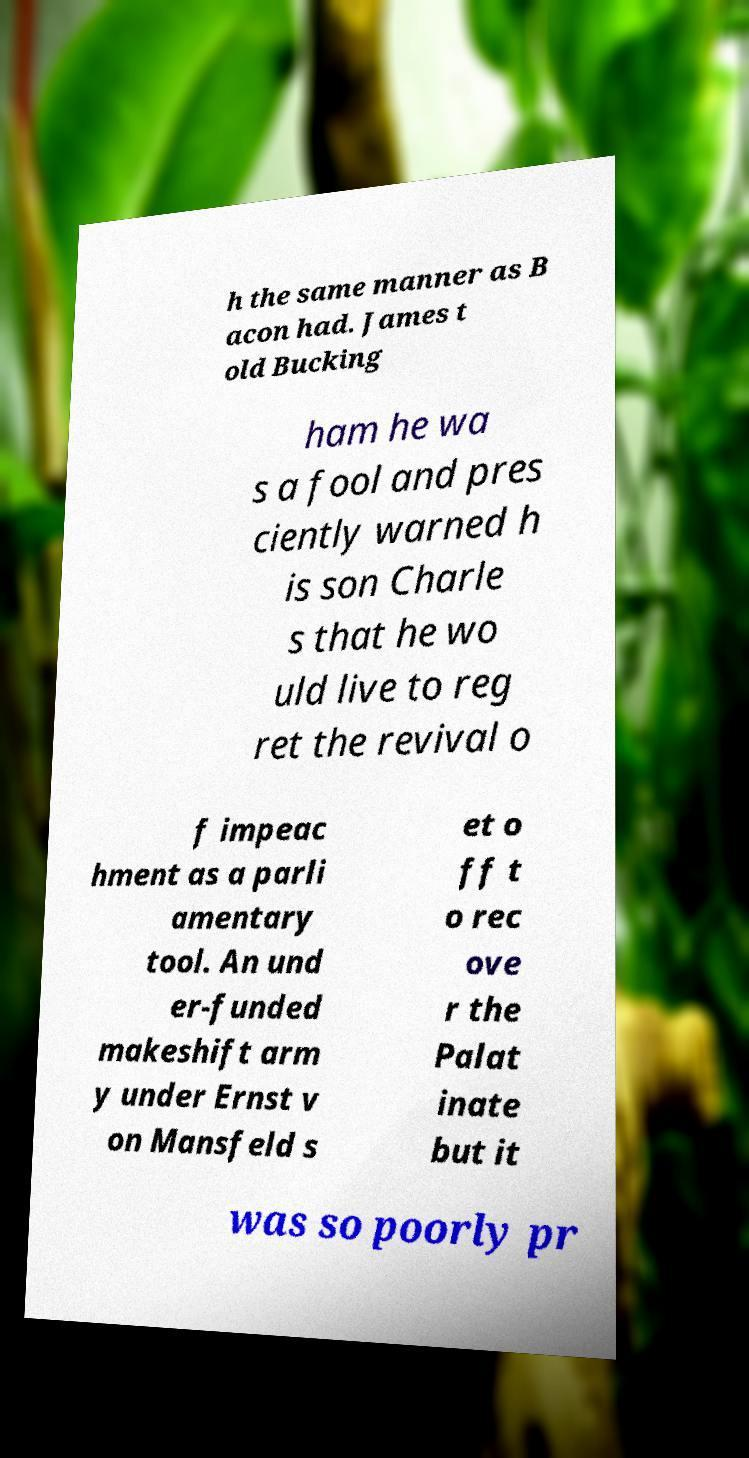Please read and relay the text visible in this image. What does it say? h the same manner as B acon had. James t old Bucking ham he wa s a fool and pres ciently warned h is son Charle s that he wo uld live to reg ret the revival o f impeac hment as a parli amentary tool. An und er-funded makeshift arm y under Ernst v on Mansfeld s et o ff t o rec ove r the Palat inate but it was so poorly pr 